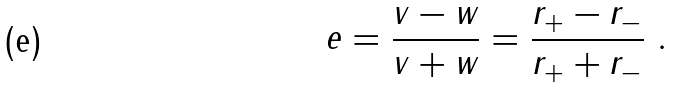<formula> <loc_0><loc_0><loc_500><loc_500>e = \frac { v - w } { v + w } = \frac { r _ { + } - r _ { - } } { r _ { + } + r _ { - } } \ .</formula> 